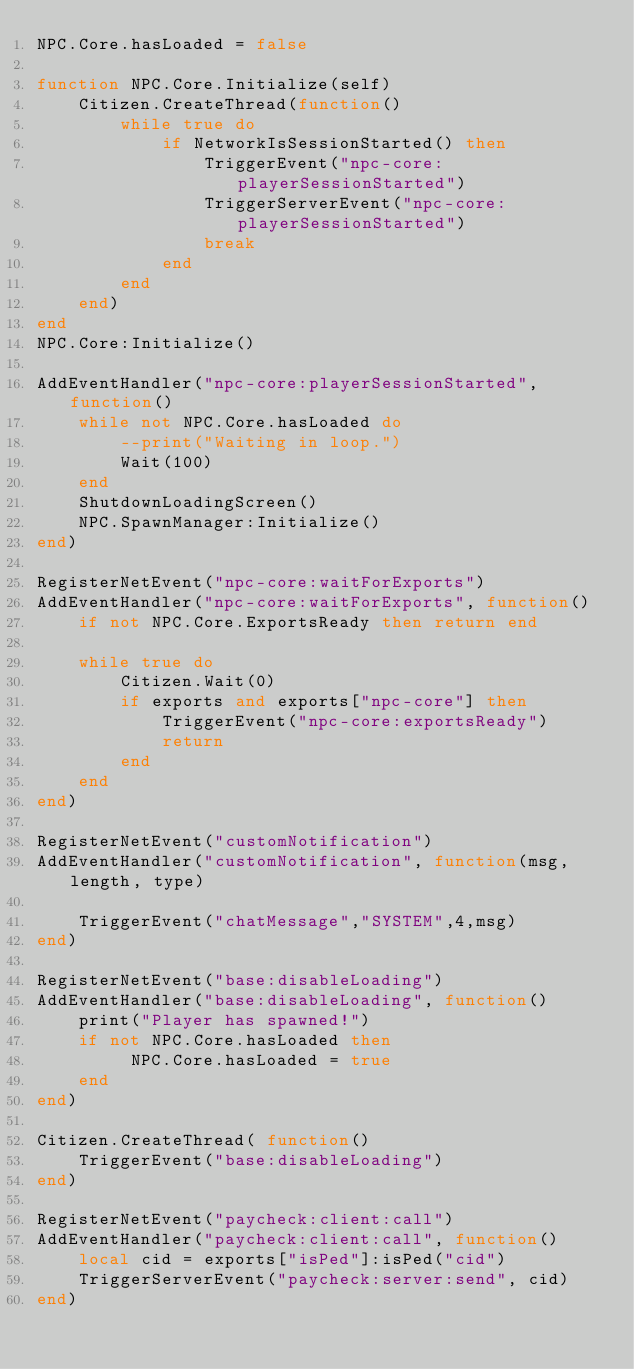Convert code to text. <code><loc_0><loc_0><loc_500><loc_500><_Lua_>NPC.Core.hasLoaded = false

function NPC.Core.Initialize(self)
    Citizen.CreateThread(function()
        while true do
            if NetworkIsSessionStarted() then
                TriggerEvent("npc-core:playerSessionStarted")
                TriggerServerEvent("npc-core:playerSessionStarted")
                break
            end
        end
    end)
end
NPC.Core:Initialize()

AddEventHandler("npc-core:playerSessionStarted", function()
    while not NPC.Core.hasLoaded do
        --print("Waiting in loop.")
        Wait(100)
    end
    ShutdownLoadingScreen()
    NPC.SpawnManager:Initialize()
end)

RegisterNetEvent("npc-core:waitForExports")
AddEventHandler("npc-core:waitForExports", function()
    if not NPC.Core.ExportsReady then return end

    while true do
        Citizen.Wait(0)
        if exports and exports["npc-core"] then
            TriggerEvent("npc-core:exportsReady")
            return
        end
    end
end)

RegisterNetEvent("customNotification")
AddEventHandler("customNotification", function(msg, length, type)

	TriggerEvent("chatMessage","SYSTEM",4,msg)
end)

RegisterNetEvent("base:disableLoading")
AddEventHandler("base:disableLoading", function()
    print("Player has spawned!")
    if not NPC.Core.hasLoaded then
         NPC.Core.hasLoaded = true
    end
end)

Citizen.CreateThread( function()
    TriggerEvent("base:disableLoading")
end)

RegisterNetEvent("paycheck:client:call")
AddEventHandler("paycheck:client:call", function()
    local cid = exports["isPed"]:isPed("cid")
    TriggerServerEvent("paycheck:server:send", cid)
end)</code> 